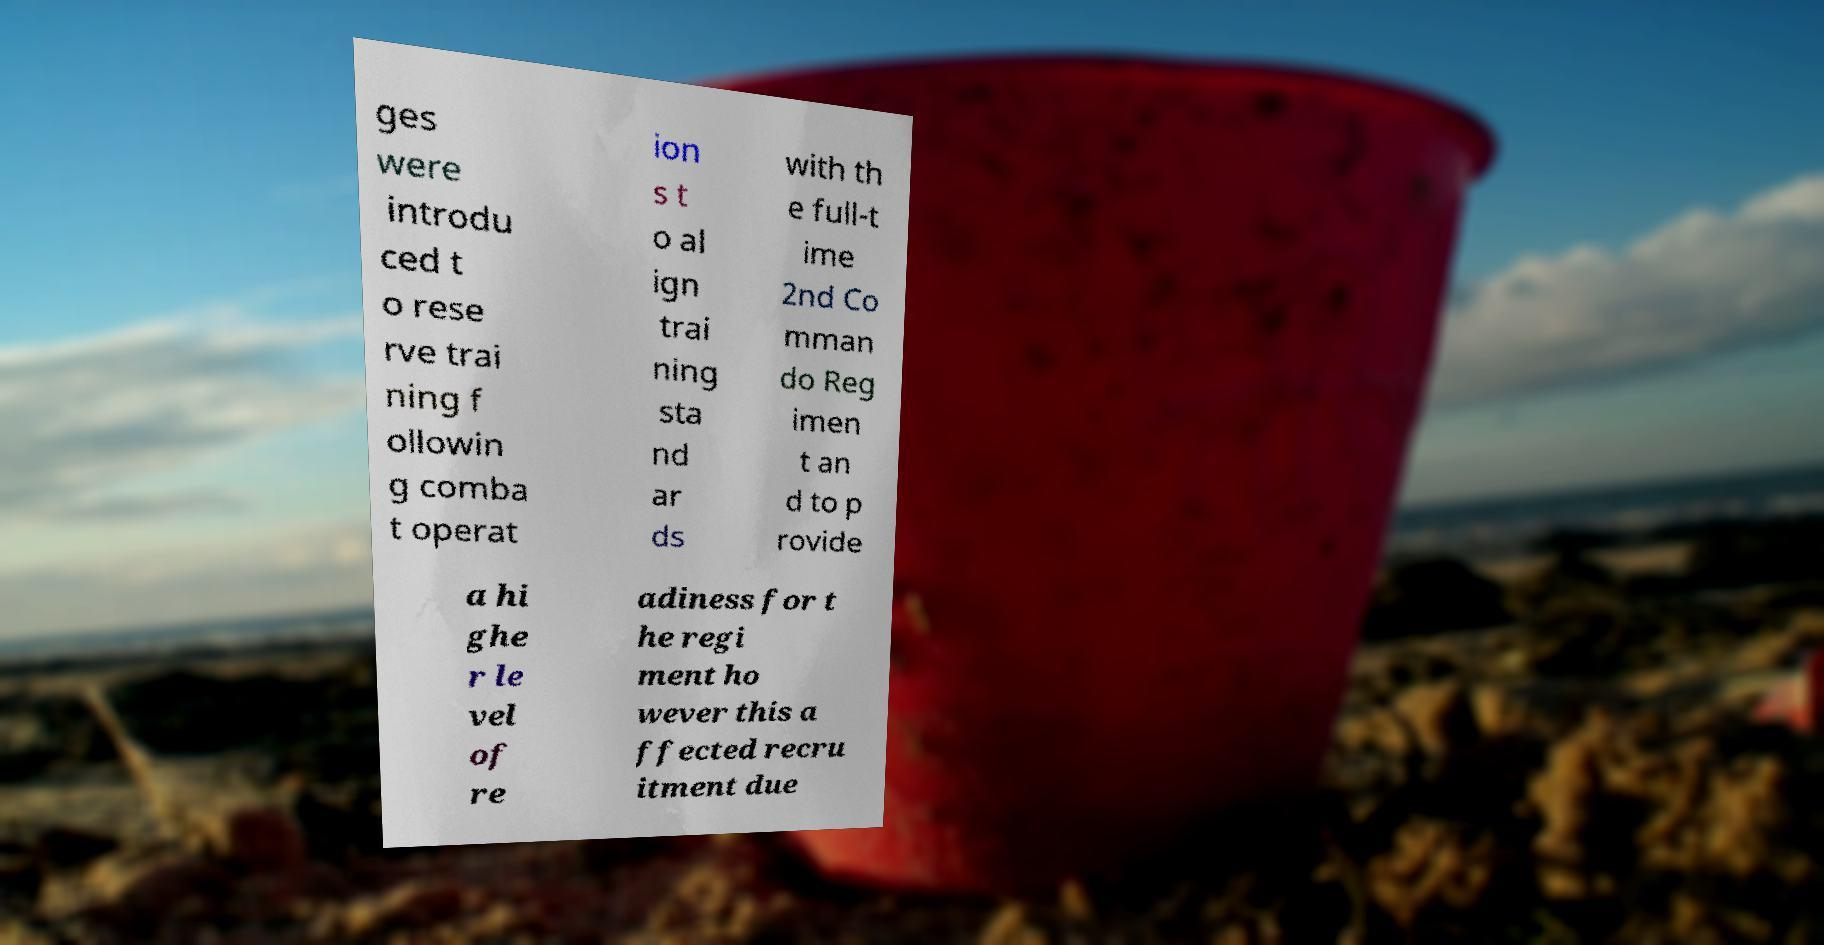Please read and relay the text visible in this image. What does it say? ges were introdu ced t o rese rve trai ning f ollowin g comba t operat ion s t o al ign trai ning sta nd ar ds with th e full-t ime 2nd Co mman do Reg imen t an d to p rovide a hi ghe r le vel of re adiness for t he regi ment ho wever this a ffected recru itment due 